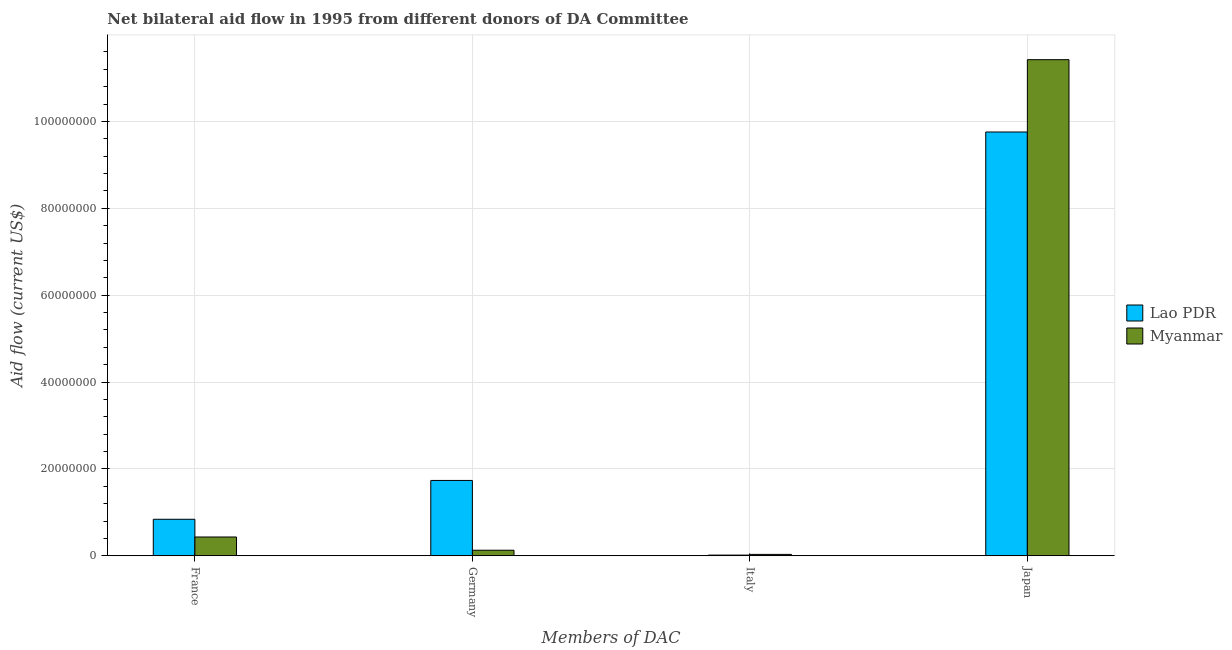What is the amount of aid given by italy in Myanmar?
Ensure brevity in your answer.  3.20e+05. Across all countries, what is the maximum amount of aid given by germany?
Ensure brevity in your answer.  1.74e+07. Across all countries, what is the minimum amount of aid given by italy?
Ensure brevity in your answer.  1.60e+05. In which country was the amount of aid given by japan maximum?
Provide a short and direct response. Myanmar. In which country was the amount of aid given by italy minimum?
Ensure brevity in your answer.  Lao PDR. What is the total amount of aid given by france in the graph?
Provide a short and direct response. 1.27e+07. What is the difference between the amount of aid given by germany in Myanmar and that in Lao PDR?
Provide a short and direct response. -1.61e+07. What is the difference between the amount of aid given by france in Myanmar and the amount of aid given by japan in Lao PDR?
Offer a very short reply. -9.32e+07. What is the average amount of aid given by france per country?
Your answer should be very brief. 6.37e+06. What is the difference between the amount of aid given by italy and amount of aid given by germany in Lao PDR?
Keep it short and to the point. -1.72e+07. In how many countries, is the amount of aid given by japan greater than 16000000 US$?
Make the answer very short. 2. What is the ratio of the amount of aid given by japan in Lao PDR to that in Myanmar?
Ensure brevity in your answer.  0.85. Is the amount of aid given by italy in Myanmar less than that in Lao PDR?
Offer a very short reply. No. What is the difference between the highest and the second highest amount of aid given by japan?
Keep it short and to the point. 1.66e+07. What is the difference between the highest and the lowest amount of aid given by italy?
Provide a short and direct response. 1.60e+05. In how many countries, is the amount of aid given by france greater than the average amount of aid given by france taken over all countries?
Offer a very short reply. 1. Is the sum of the amount of aid given by italy in Lao PDR and Myanmar greater than the maximum amount of aid given by japan across all countries?
Offer a terse response. No. What does the 2nd bar from the left in Japan represents?
Give a very brief answer. Myanmar. What does the 2nd bar from the right in Italy represents?
Provide a succinct answer. Lao PDR. Is it the case that in every country, the sum of the amount of aid given by france and amount of aid given by germany is greater than the amount of aid given by italy?
Provide a succinct answer. Yes. Are all the bars in the graph horizontal?
Provide a succinct answer. No. How many countries are there in the graph?
Your answer should be compact. 2. Does the graph contain any zero values?
Keep it short and to the point. No. Where does the legend appear in the graph?
Your answer should be compact. Center right. What is the title of the graph?
Offer a terse response. Net bilateral aid flow in 1995 from different donors of DA Committee. What is the label or title of the X-axis?
Offer a terse response. Members of DAC. What is the label or title of the Y-axis?
Your response must be concise. Aid flow (current US$). What is the Aid flow (current US$) of Lao PDR in France?
Offer a very short reply. 8.41e+06. What is the Aid flow (current US$) in Myanmar in France?
Your answer should be very brief. 4.33e+06. What is the Aid flow (current US$) in Lao PDR in Germany?
Your answer should be very brief. 1.74e+07. What is the Aid flow (current US$) in Myanmar in Germany?
Your answer should be very brief. 1.28e+06. What is the Aid flow (current US$) of Myanmar in Italy?
Provide a short and direct response. 3.20e+05. What is the Aid flow (current US$) of Lao PDR in Japan?
Offer a terse response. 9.76e+07. What is the Aid flow (current US$) in Myanmar in Japan?
Offer a terse response. 1.14e+08. Across all Members of DAC, what is the maximum Aid flow (current US$) of Lao PDR?
Offer a very short reply. 9.76e+07. Across all Members of DAC, what is the maximum Aid flow (current US$) in Myanmar?
Ensure brevity in your answer.  1.14e+08. Across all Members of DAC, what is the minimum Aid flow (current US$) of Lao PDR?
Provide a succinct answer. 1.60e+05. Across all Members of DAC, what is the minimum Aid flow (current US$) of Myanmar?
Your response must be concise. 3.20e+05. What is the total Aid flow (current US$) of Lao PDR in the graph?
Keep it short and to the point. 1.24e+08. What is the total Aid flow (current US$) of Myanmar in the graph?
Make the answer very short. 1.20e+08. What is the difference between the Aid flow (current US$) of Lao PDR in France and that in Germany?
Your answer should be compact. -8.94e+06. What is the difference between the Aid flow (current US$) in Myanmar in France and that in Germany?
Provide a short and direct response. 3.05e+06. What is the difference between the Aid flow (current US$) of Lao PDR in France and that in Italy?
Your answer should be compact. 8.25e+06. What is the difference between the Aid flow (current US$) of Myanmar in France and that in Italy?
Your response must be concise. 4.01e+06. What is the difference between the Aid flow (current US$) of Lao PDR in France and that in Japan?
Provide a succinct answer. -8.92e+07. What is the difference between the Aid flow (current US$) in Myanmar in France and that in Japan?
Ensure brevity in your answer.  -1.10e+08. What is the difference between the Aid flow (current US$) in Lao PDR in Germany and that in Italy?
Keep it short and to the point. 1.72e+07. What is the difference between the Aid flow (current US$) of Myanmar in Germany and that in Italy?
Provide a succinct answer. 9.60e+05. What is the difference between the Aid flow (current US$) of Lao PDR in Germany and that in Japan?
Provide a succinct answer. -8.02e+07. What is the difference between the Aid flow (current US$) of Myanmar in Germany and that in Japan?
Your answer should be compact. -1.13e+08. What is the difference between the Aid flow (current US$) in Lao PDR in Italy and that in Japan?
Give a very brief answer. -9.74e+07. What is the difference between the Aid flow (current US$) in Myanmar in Italy and that in Japan?
Your answer should be very brief. -1.14e+08. What is the difference between the Aid flow (current US$) in Lao PDR in France and the Aid flow (current US$) in Myanmar in Germany?
Your response must be concise. 7.13e+06. What is the difference between the Aid flow (current US$) in Lao PDR in France and the Aid flow (current US$) in Myanmar in Italy?
Your answer should be compact. 8.09e+06. What is the difference between the Aid flow (current US$) of Lao PDR in France and the Aid flow (current US$) of Myanmar in Japan?
Ensure brevity in your answer.  -1.06e+08. What is the difference between the Aid flow (current US$) of Lao PDR in Germany and the Aid flow (current US$) of Myanmar in Italy?
Make the answer very short. 1.70e+07. What is the difference between the Aid flow (current US$) of Lao PDR in Germany and the Aid flow (current US$) of Myanmar in Japan?
Your answer should be very brief. -9.69e+07. What is the difference between the Aid flow (current US$) in Lao PDR in Italy and the Aid flow (current US$) in Myanmar in Japan?
Make the answer very short. -1.14e+08. What is the average Aid flow (current US$) of Lao PDR per Members of DAC?
Offer a very short reply. 3.09e+07. What is the average Aid flow (current US$) of Myanmar per Members of DAC?
Make the answer very short. 3.00e+07. What is the difference between the Aid flow (current US$) of Lao PDR and Aid flow (current US$) of Myanmar in France?
Offer a terse response. 4.08e+06. What is the difference between the Aid flow (current US$) in Lao PDR and Aid flow (current US$) in Myanmar in Germany?
Provide a succinct answer. 1.61e+07. What is the difference between the Aid flow (current US$) of Lao PDR and Aid flow (current US$) of Myanmar in Italy?
Ensure brevity in your answer.  -1.60e+05. What is the difference between the Aid flow (current US$) of Lao PDR and Aid flow (current US$) of Myanmar in Japan?
Provide a succinct answer. -1.66e+07. What is the ratio of the Aid flow (current US$) in Lao PDR in France to that in Germany?
Your answer should be very brief. 0.48. What is the ratio of the Aid flow (current US$) in Myanmar in France to that in Germany?
Offer a terse response. 3.38. What is the ratio of the Aid flow (current US$) in Lao PDR in France to that in Italy?
Keep it short and to the point. 52.56. What is the ratio of the Aid flow (current US$) in Myanmar in France to that in Italy?
Provide a short and direct response. 13.53. What is the ratio of the Aid flow (current US$) of Lao PDR in France to that in Japan?
Provide a succinct answer. 0.09. What is the ratio of the Aid flow (current US$) of Myanmar in France to that in Japan?
Provide a succinct answer. 0.04. What is the ratio of the Aid flow (current US$) of Lao PDR in Germany to that in Italy?
Keep it short and to the point. 108.44. What is the ratio of the Aid flow (current US$) in Myanmar in Germany to that in Italy?
Make the answer very short. 4. What is the ratio of the Aid flow (current US$) in Lao PDR in Germany to that in Japan?
Offer a very short reply. 0.18. What is the ratio of the Aid flow (current US$) in Myanmar in Germany to that in Japan?
Your answer should be compact. 0.01. What is the ratio of the Aid flow (current US$) of Lao PDR in Italy to that in Japan?
Keep it short and to the point. 0. What is the ratio of the Aid flow (current US$) of Myanmar in Italy to that in Japan?
Provide a short and direct response. 0. What is the difference between the highest and the second highest Aid flow (current US$) of Lao PDR?
Your answer should be compact. 8.02e+07. What is the difference between the highest and the second highest Aid flow (current US$) in Myanmar?
Keep it short and to the point. 1.10e+08. What is the difference between the highest and the lowest Aid flow (current US$) in Lao PDR?
Provide a succinct answer. 9.74e+07. What is the difference between the highest and the lowest Aid flow (current US$) in Myanmar?
Your answer should be very brief. 1.14e+08. 